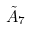<formula> <loc_0><loc_0><loc_500><loc_500>\tilde { A } _ { 7 }</formula> 